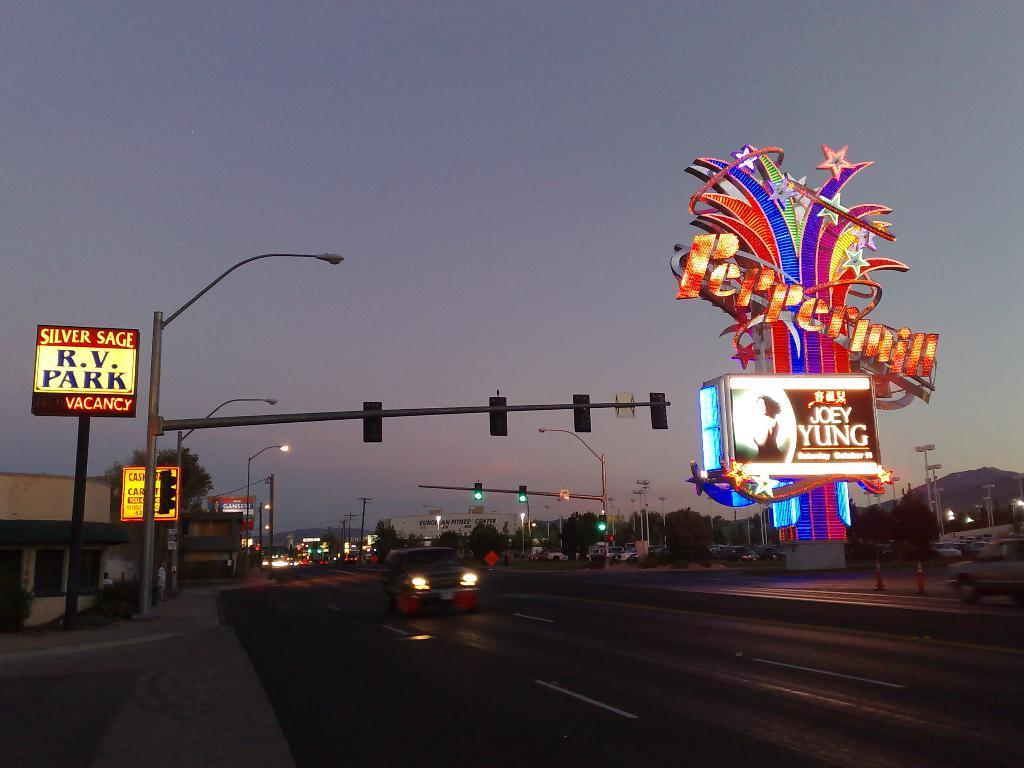Provide a one-sentence caption for the provided image. Joey Yung will be performing at the Pepermill in October. 